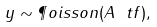<formula> <loc_0><loc_0><loc_500><loc_500>y \sim \P o i s s o n ( A \ t f ) ,</formula> 